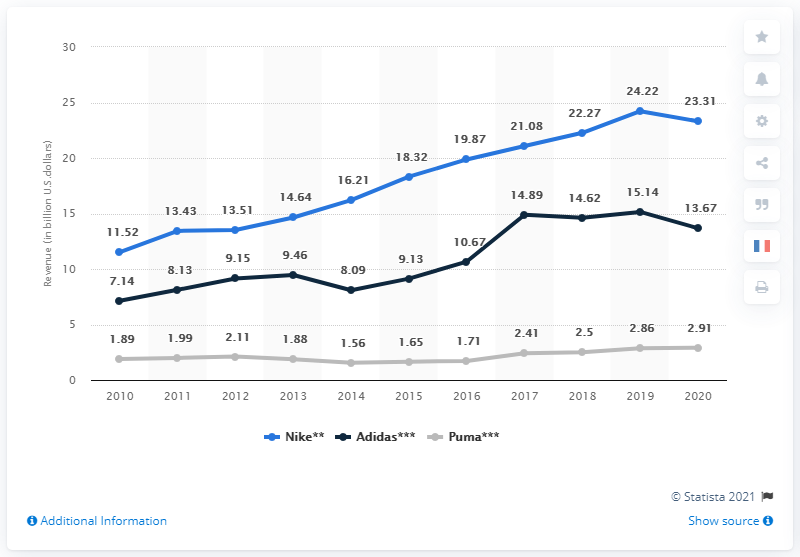Identify some key points in this picture. The rightmost value written on top of the black line is 13.67 and above. In 2020, Adidas' revenue from footwear was approximately 13.67 billion dollars. In 2012, the difference in revenue between Nike and Adidas in the footwear market was minimal. 